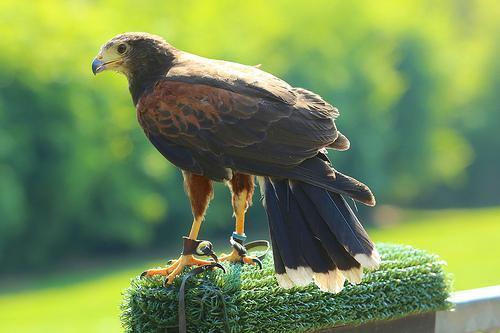How many birds tied?
Give a very brief answer. 1. 